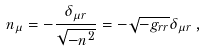Convert formula to latex. <formula><loc_0><loc_0><loc_500><loc_500>n _ { \mu } = - \frac { \delta _ { \mu r } } { \sqrt { - n ^ { 2 } } } = - \sqrt { - g _ { r r } } \delta _ { \mu r } \, ,</formula> 